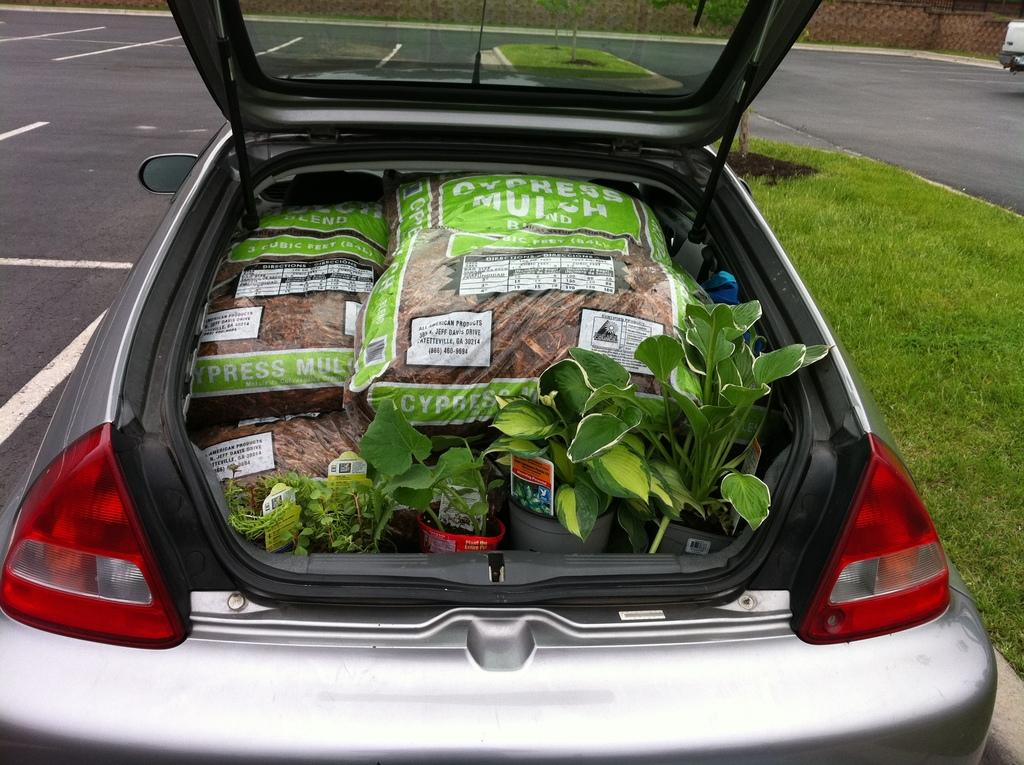What is the main subject of the image? The main subject of the image is a car. What can be seen inside the car? There are bags and plants in the car. What is unusual about the road in the image? There is grass in the middle of the road. What type of religious ceremony is taking place in the car? There is no indication of a religious ceremony taking place in the car; the image only shows a car with bags and plants inside. 